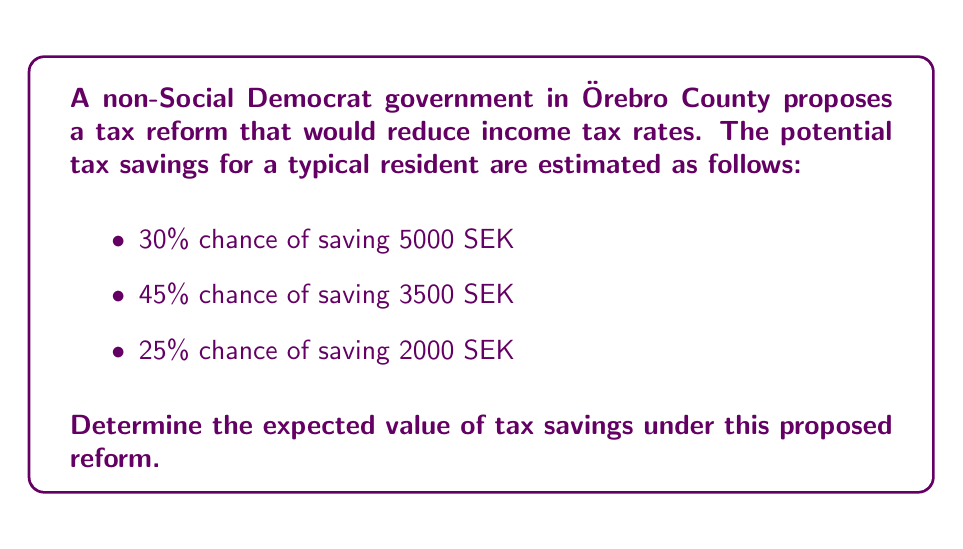Solve this math problem. To calculate the expected value of tax savings, we need to multiply each possible outcome by its probability and then sum these products.

Let's define our random variable X as the tax savings in SEK.

Step 1: Identify the probability distribution
$$P(X = 5000) = 0.30$$
$$P(X = 3500) = 0.45$$
$$P(X = 2000) = 0.25$$

Step 2: Calculate the expected value using the formula
$$E(X) = \sum_{i} x_i \cdot P(X = x_i)$$

Step 3: Substitute the values and calculate
$$E(X) = 5000 \cdot 0.30 + 3500 \cdot 0.45 + 2000 \cdot 0.25$$
$$E(X) = 1500 + 1575 + 500$$
$$E(X) = 3575$$

Therefore, the expected value of tax savings under the proposed non-Social Democrat government reform is 3575 SEK.
Answer: 3575 SEK 